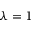Convert formula to latex. <formula><loc_0><loc_0><loc_500><loc_500>\lambda = 1</formula> 